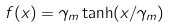<formula> <loc_0><loc_0><loc_500><loc_500>f ( x ) = \gamma _ { m } \tanh ( x / \gamma _ { m } )</formula> 